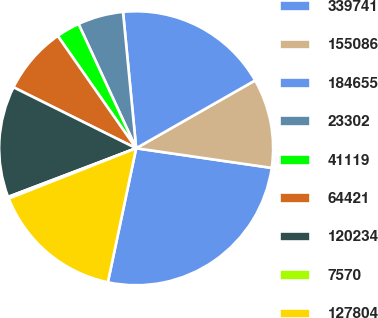Convert chart. <chart><loc_0><loc_0><loc_500><loc_500><pie_chart><fcel>339741<fcel>155086<fcel>184655<fcel>23302<fcel>41119<fcel>64421<fcel>120234<fcel>7570<fcel>127804<nl><fcel>26.02%<fcel>10.54%<fcel>18.28%<fcel>5.38%<fcel>2.79%<fcel>7.96%<fcel>13.12%<fcel>0.21%<fcel>15.7%<nl></chart> 